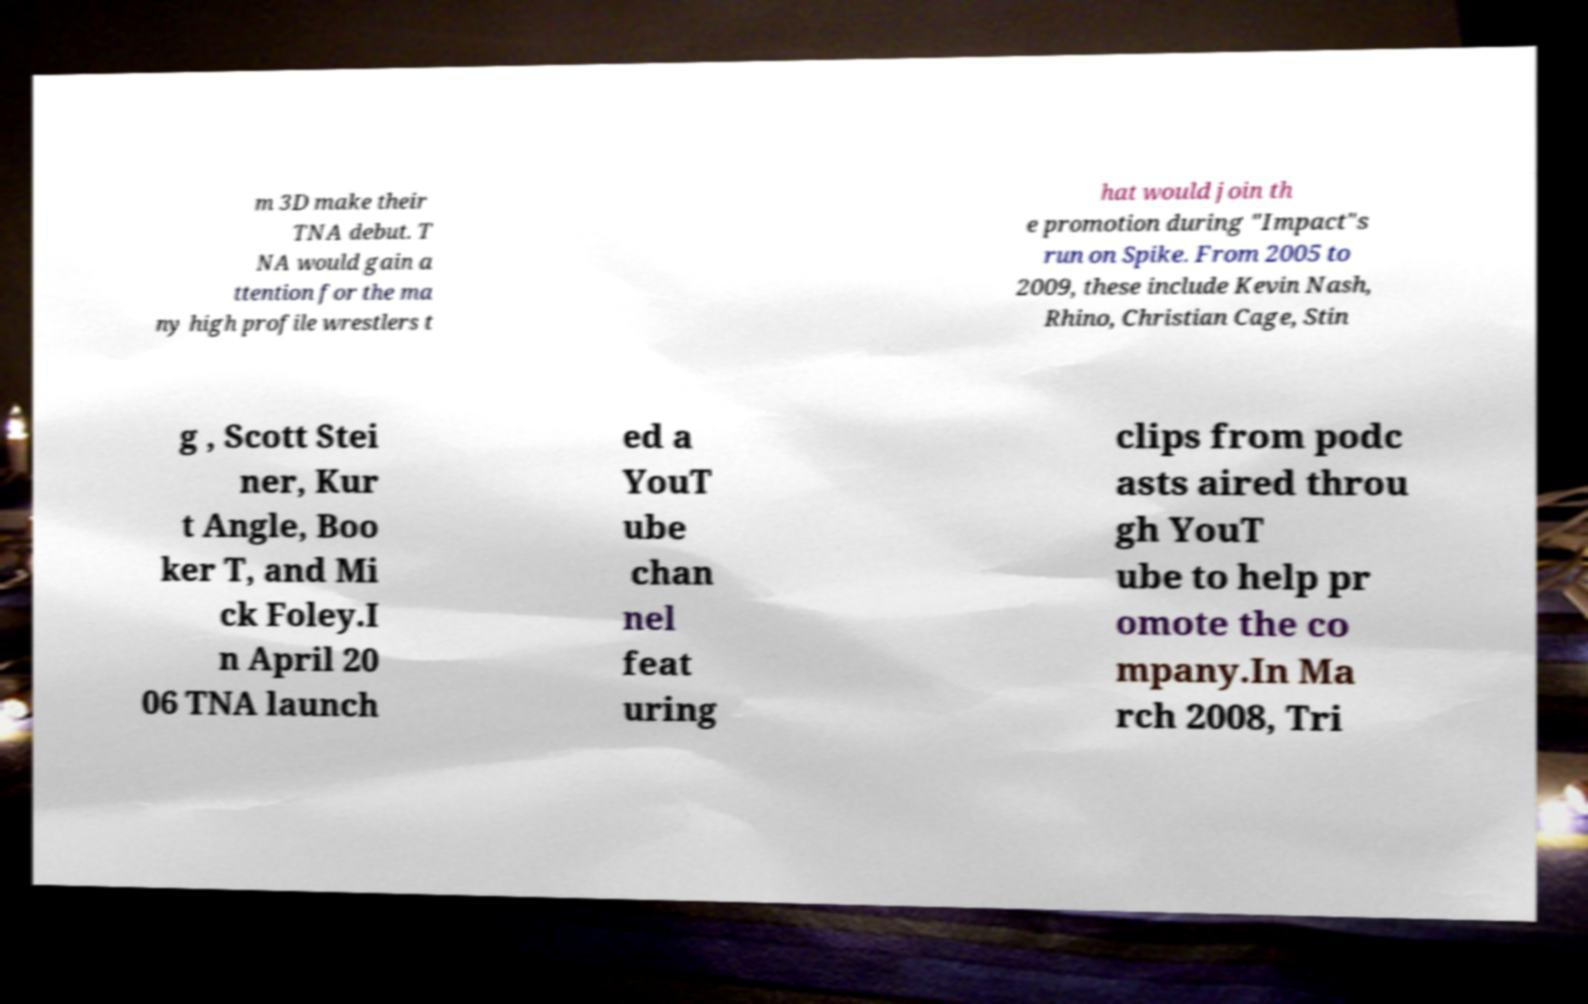Please read and relay the text visible in this image. What does it say? m 3D make their TNA debut. T NA would gain a ttention for the ma ny high profile wrestlers t hat would join th e promotion during "Impact"s run on Spike. From 2005 to 2009, these include Kevin Nash, Rhino, Christian Cage, Stin g , Scott Stei ner, Kur t Angle, Boo ker T, and Mi ck Foley.I n April 20 06 TNA launch ed a YouT ube chan nel feat uring clips from podc asts aired throu gh YouT ube to help pr omote the co mpany.In Ma rch 2008, Tri 